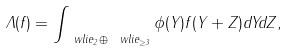<formula> <loc_0><loc_0><loc_500><loc_500>\Lambda ( f ) = \int _ { \ w l i e _ { 2 } \oplus \ w l i e _ { \geq 3 } } \phi ( Y ) f ( Y + Z ) d Y d Z ,</formula> 